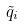<formula> <loc_0><loc_0><loc_500><loc_500>\tilde { q } _ { i }</formula> 